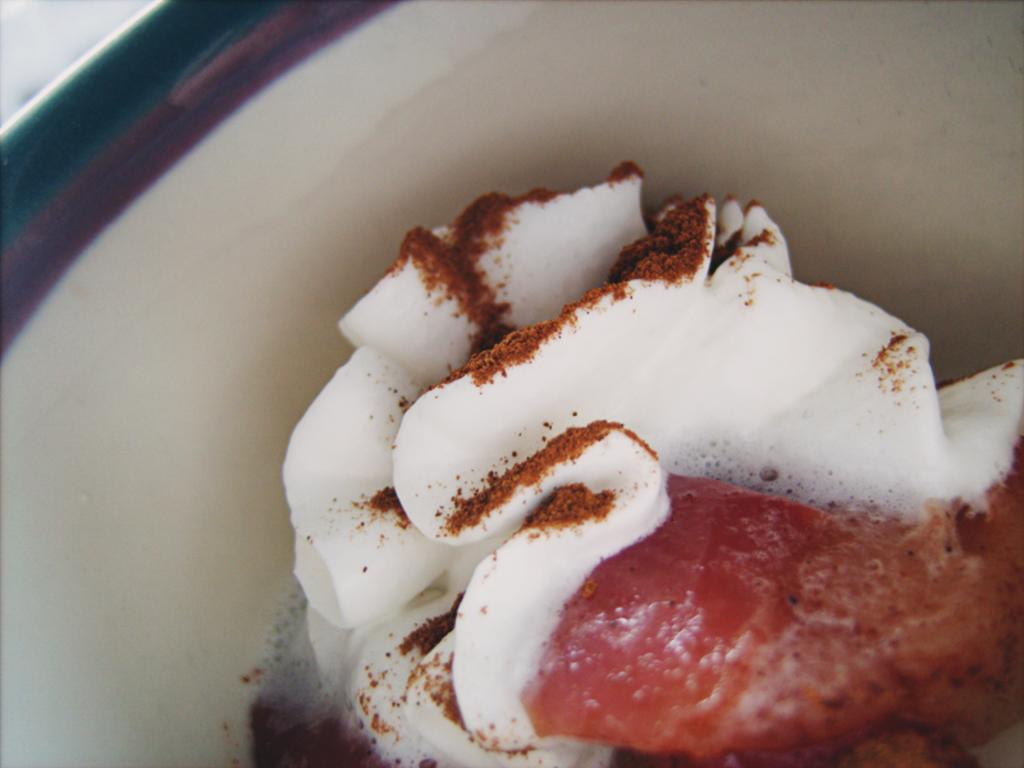What type of food is visible in the image? There is a pastry in the image. Where is the pastry located? The pastry is in a bowl. What is sprinkled on the pastry? Cocoa powder is present on the pastry. What type of tank can be seen in the image? There is no tank present in the image; it features a pastry in a bowl with cocoa powder. How many cabbages are visible in the image? There are no cabbages present in the image; it features a pastry in a bowl with cocoa powder. 